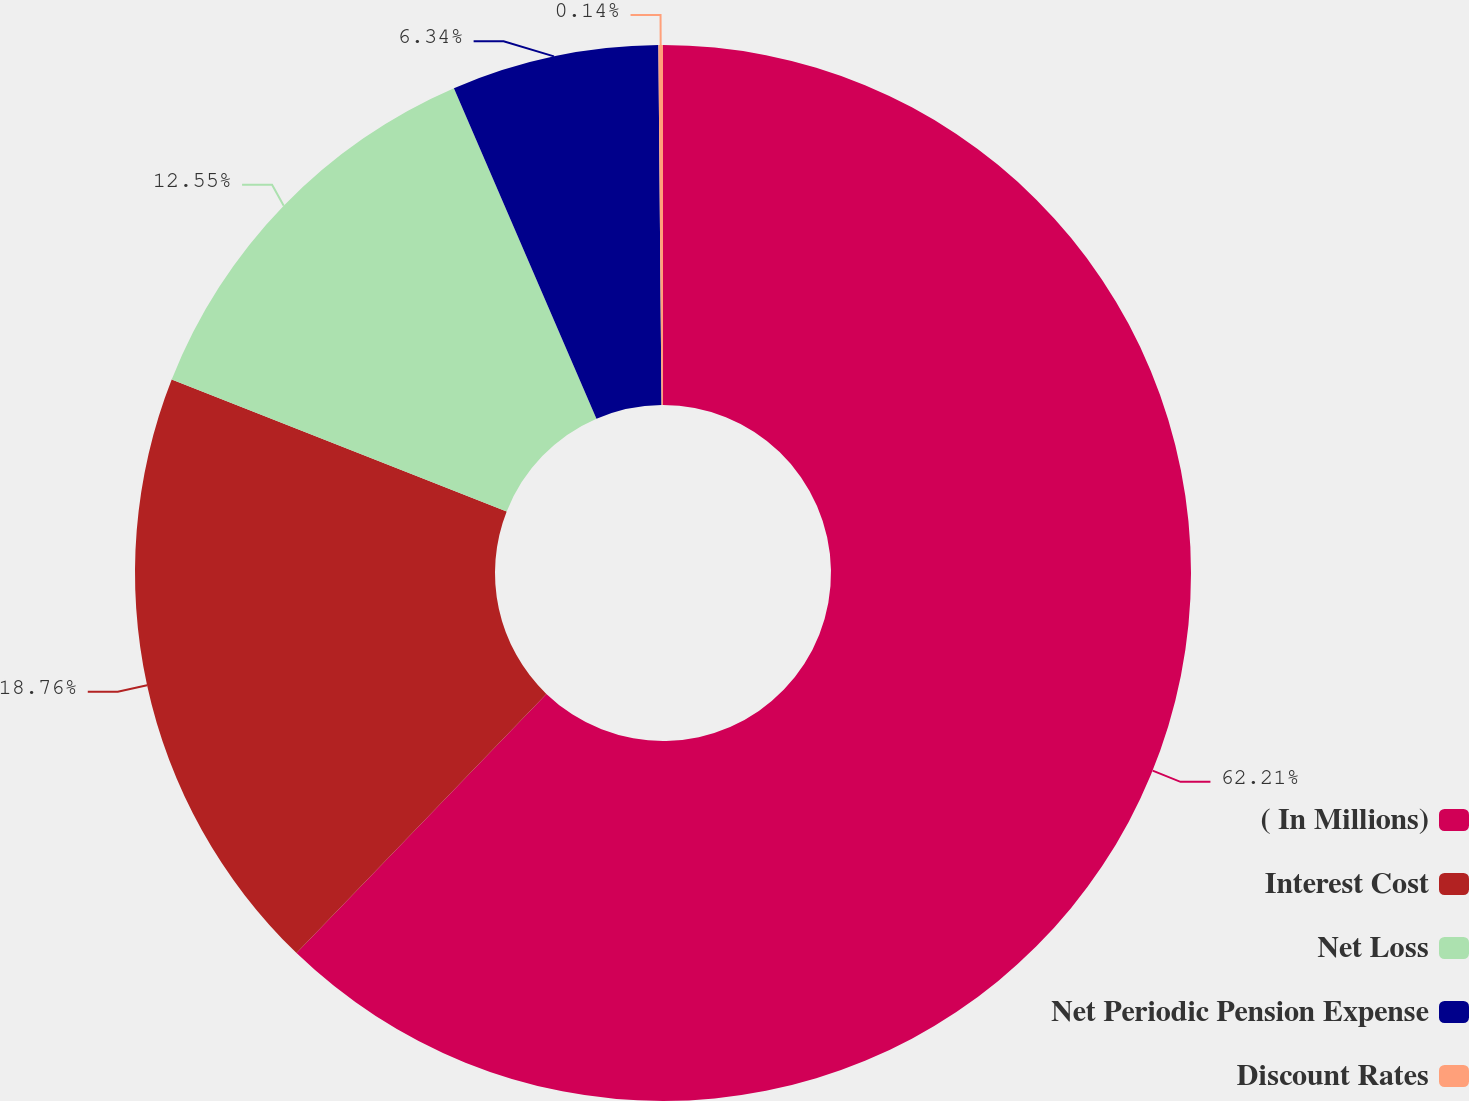<chart> <loc_0><loc_0><loc_500><loc_500><pie_chart><fcel>( In Millions)<fcel>Interest Cost<fcel>Net Loss<fcel>Net Periodic Pension Expense<fcel>Discount Rates<nl><fcel>62.21%<fcel>18.76%<fcel>12.55%<fcel>6.34%<fcel>0.14%<nl></chart> 